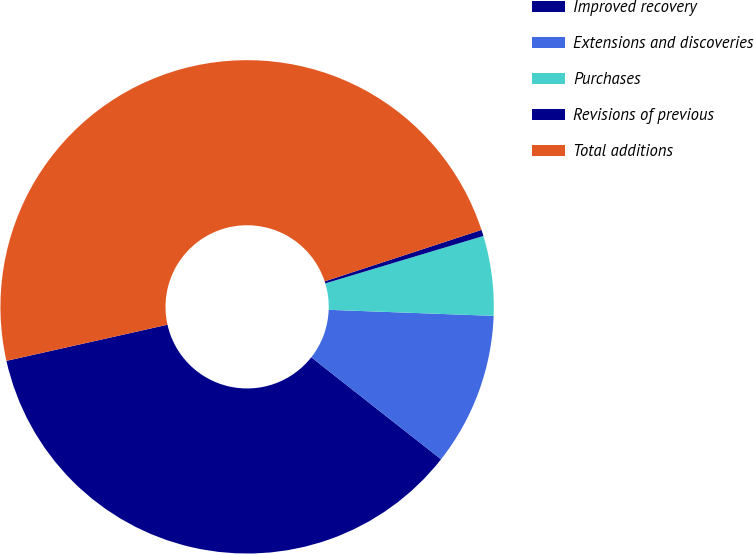<chart> <loc_0><loc_0><loc_500><loc_500><pie_chart><fcel>Improved recovery<fcel>Extensions and discoveries<fcel>Purchases<fcel>Revisions of previous<fcel>Total additions<nl><fcel>35.88%<fcel>10.02%<fcel>5.22%<fcel>0.41%<fcel>48.46%<nl></chart> 